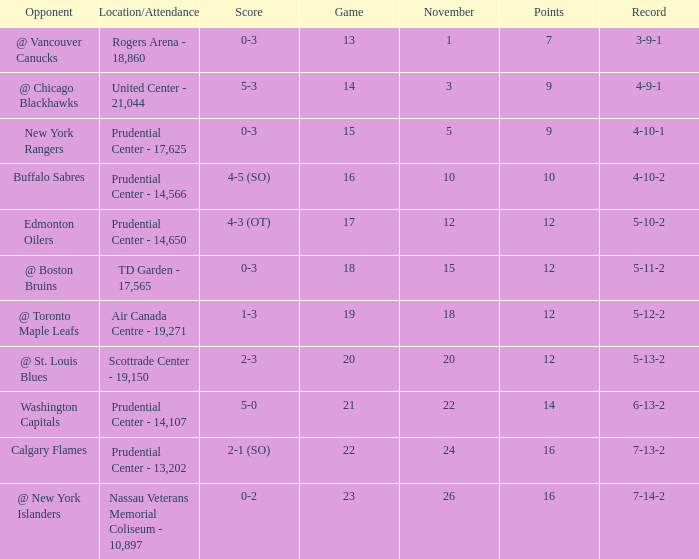Who was the opponent where the game is 14? @ Chicago Blackhawks. 